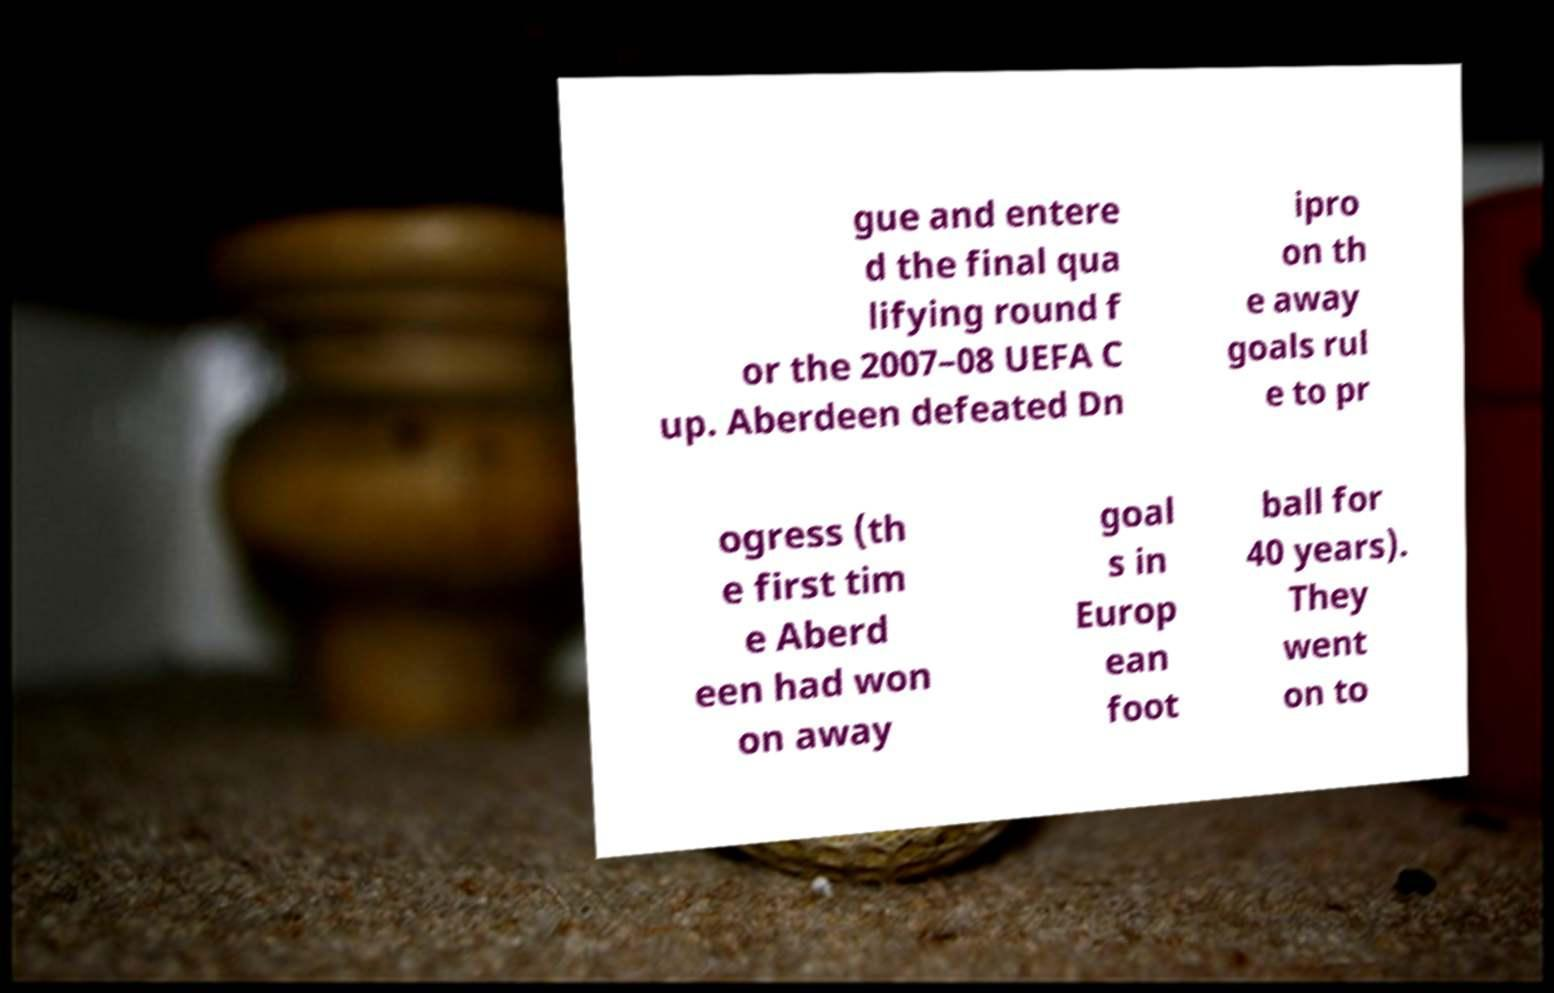Can you read and provide the text displayed in the image?This photo seems to have some interesting text. Can you extract and type it out for me? gue and entere d the final qua lifying round f or the 2007–08 UEFA C up. Aberdeen defeated Dn ipro on th e away goals rul e to pr ogress (th e first tim e Aberd een had won on away goal s in Europ ean foot ball for 40 years). They went on to 